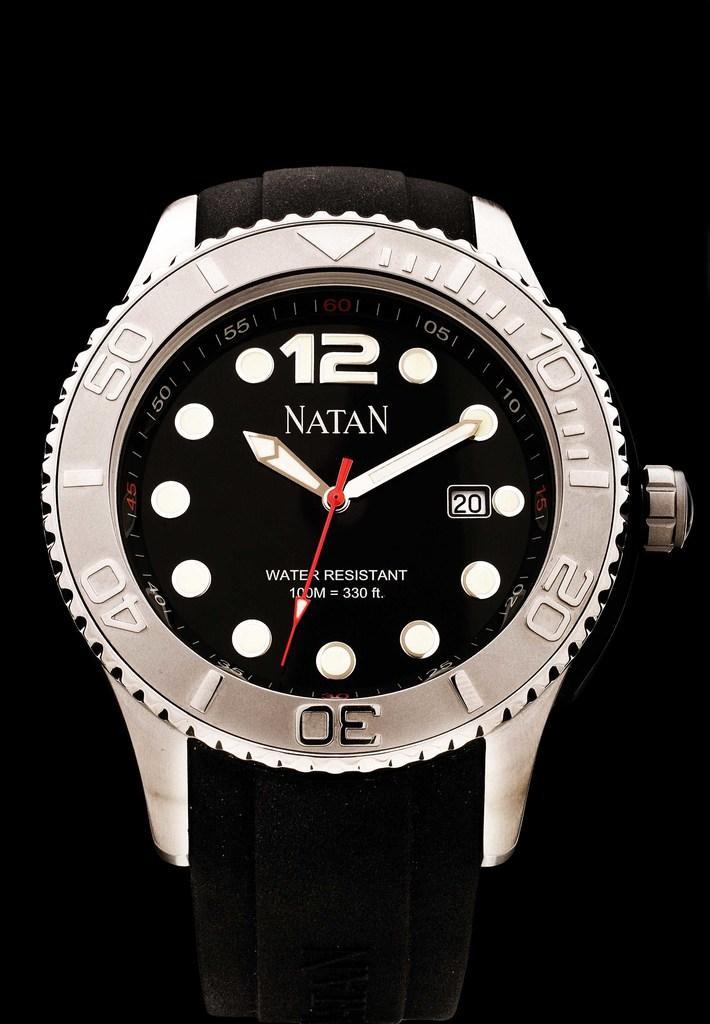Can you describe this image briefly? In the picture we can see a wrist watch and with a white frame and in it we can see a name Nathan and to the left hand side there is a button. 